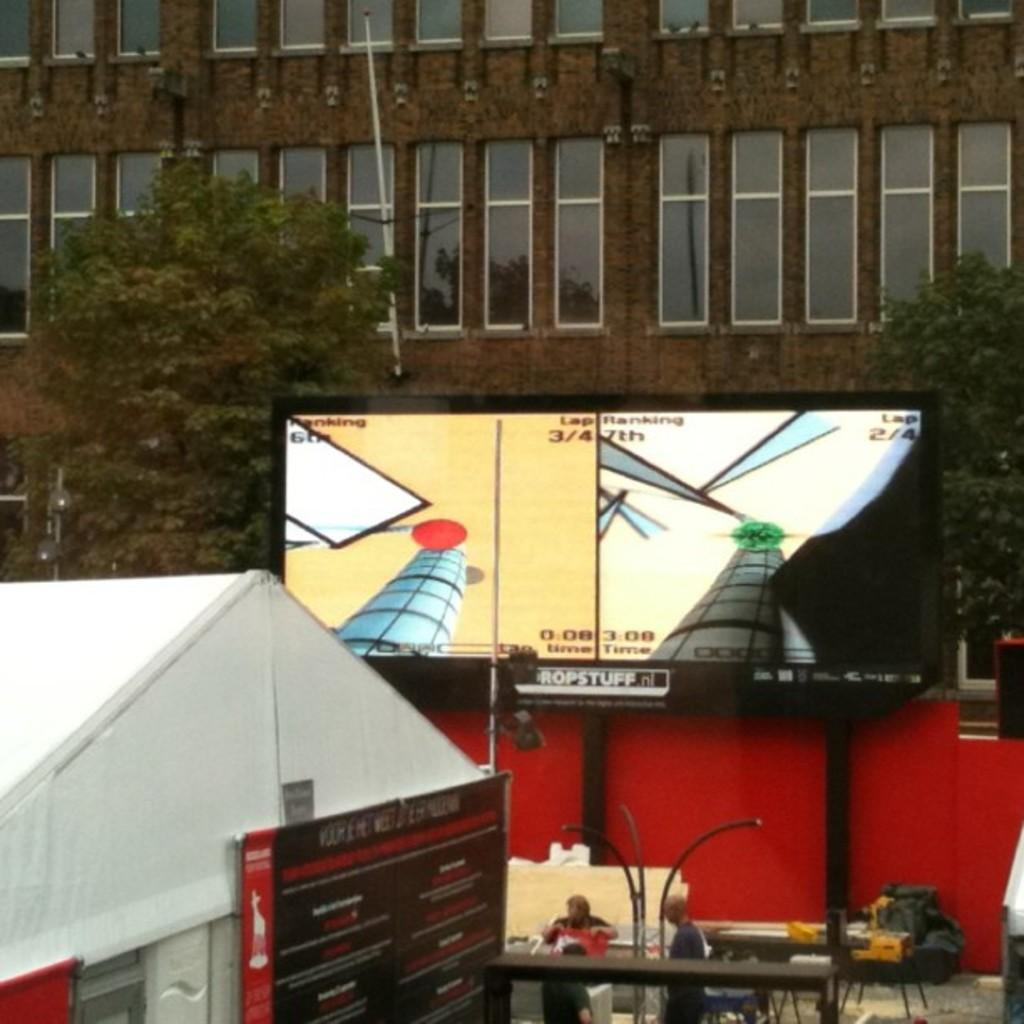What type of structures can be seen in the image? There are buildings in the image. What architectural features are visible on the buildings? There are windows visible on the buildings. What natural elements can be seen in the image? There are trees in the image. What type of signage or display is present in the image? There is a board in the image. What type of display or viewing device is present in the image? There is a screen in the image. What type of lighting infrastructure is present in the image? There are light-poles in the image. Are there any human subjects in the image? Yes, there are people in the image. What type of objects can be seen on the floor in the image? There are objects on the floor in the image. How does the basin affect the acoustics in the image? There is no basin present in the image, so it cannot affect the acoustics. Can you tell me how many people are joining the group in the image? There is no indication of people joining a group in the image; it only shows people who are already present. 